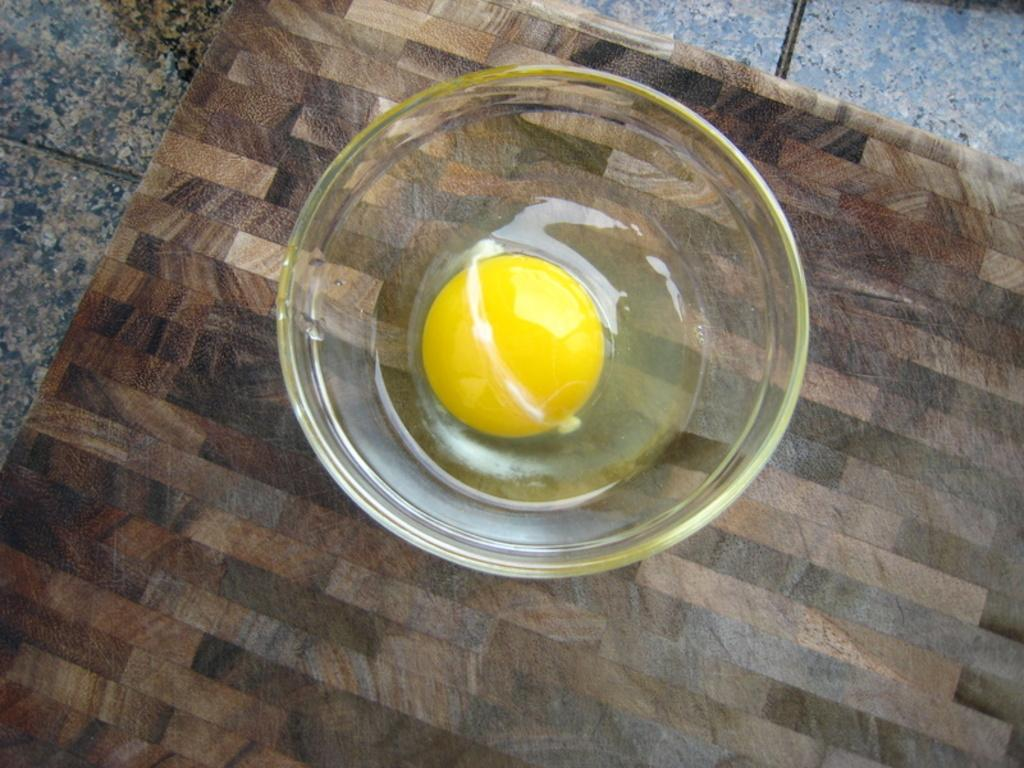What is in the bowl that is visible in the image? The bowl contains the yolk of an egg. Where is the bowl located in the image? The bowl is placed on a table. What might be the purpose of the bowl in the image? The bowl may be used for separating the yolk from the egg white or for a recipe that requires only the yolk. What type of flowers are in the vase on the table in the image? There is no vase or flowers present in the image; it only features a bowl with the yolk of an egg. Can you tell me how many people are attending the church service in the image? There is no church or people attending a service present in the image; it only features a bowl with the yolk of an egg. 